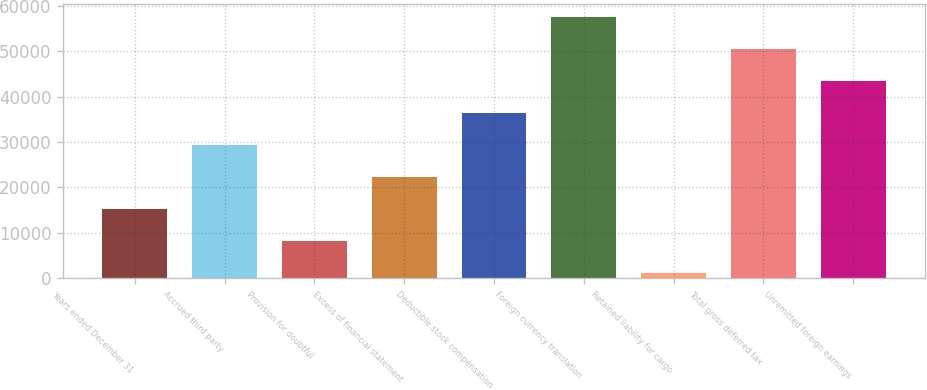<chart> <loc_0><loc_0><loc_500><loc_500><bar_chart><fcel>Years ended December 31<fcel>Accrued third party<fcel>Provision for doubtful<fcel>Excess of financial statement<fcel>Deductible stock compensation<fcel>Foreign currency translation<fcel>Retained liability for cargo<fcel>Total gross deferred tax<fcel>Unremitted foreign earnings<nl><fcel>15147.6<fcel>29270.2<fcel>8086.3<fcel>22208.9<fcel>36331.5<fcel>57515.4<fcel>1025<fcel>50454.1<fcel>43392.8<nl></chart> 